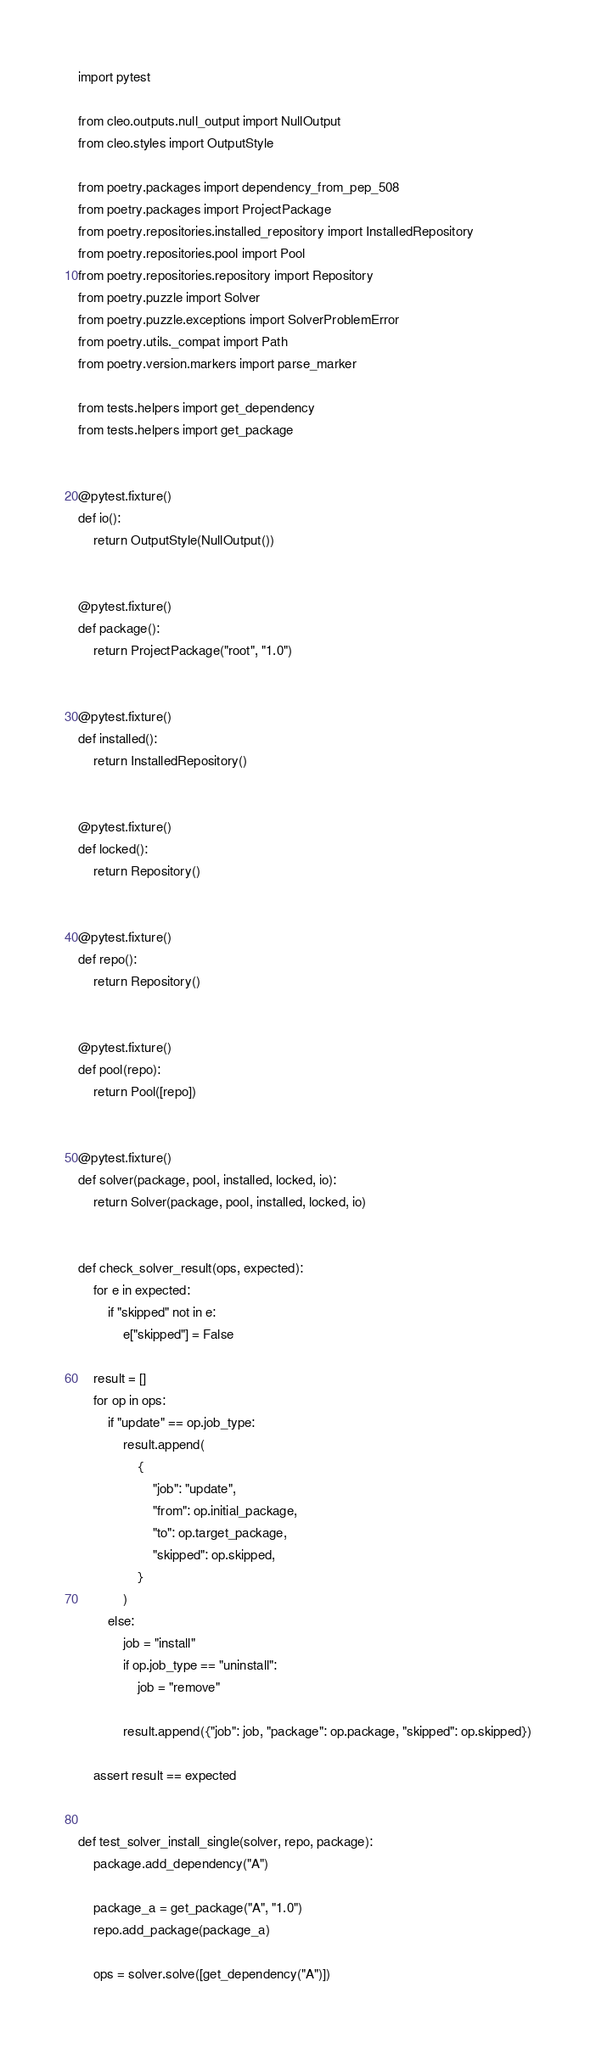<code> <loc_0><loc_0><loc_500><loc_500><_Python_>import pytest

from cleo.outputs.null_output import NullOutput
from cleo.styles import OutputStyle

from poetry.packages import dependency_from_pep_508
from poetry.packages import ProjectPackage
from poetry.repositories.installed_repository import InstalledRepository
from poetry.repositories.pool import Pool
from poetry.repositories.repository import Repository
from poetry.puzzle import Solver
from poetry.puzzle.exceptions import SolverProblemError
from poetry.utils._compat import Path
from poetry.version.markers import parse_marker

from tests.helpers import get_dependency
from tests.helpers import get_package


@pytest.fixture()
def io():
    return OutputStyle(NullOutput())


@pytest.fixture()
def package():
    return ProjectPackage("root", "1.0")


@pytest.fixture()
def installed():
    return InstalledRepository()


@pytest.fixture()
def locked():
    return Repository()


@pytest.fixture()
def repo():
    return Repository()


@pytest.fixture()
def pool(repo):
    return Pool([repo])


@pytest.fixture()
def solver(package, pool, installed, locked, io):
    return Solver(package, pool, installed, locked, io)


def check_solver_result(ops, expected):
    for e in expected:
        if "skipped" not in e:
            e["skipped"] = False

    result = []
    for op in ops:
        if "update" == op.job_type:
            result.append(
                {
                    "job": "update",
                    "from": op.initial_package,
                    "to": op.target_package,
                    "skipped": op.skipped,
                }
            )
        else:
            job = "install"
            if op.job_type == "uninstall":
                job = "remove"

            result.append({"job": job, "package": op.package, "skipped": op.skipped})

    assert result == expected


def test_solver_install_single(solver, repo, package):
    package.add_dependency("A")

    package_a = get_package("A", "1.0")
    repo.add_package(package_a)

    ops = solver.solve([get_dependency("A")])
</code> 